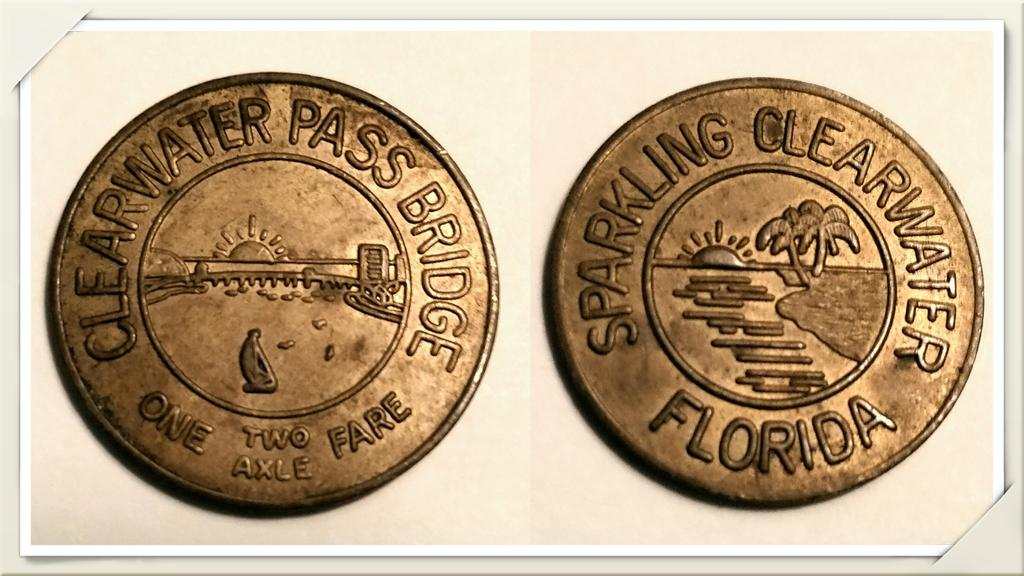<image>
Relay a brief, clear account of the picture shown. Two gold coins that say Clearwater Pass Bridge fare from Sparkling Florida 